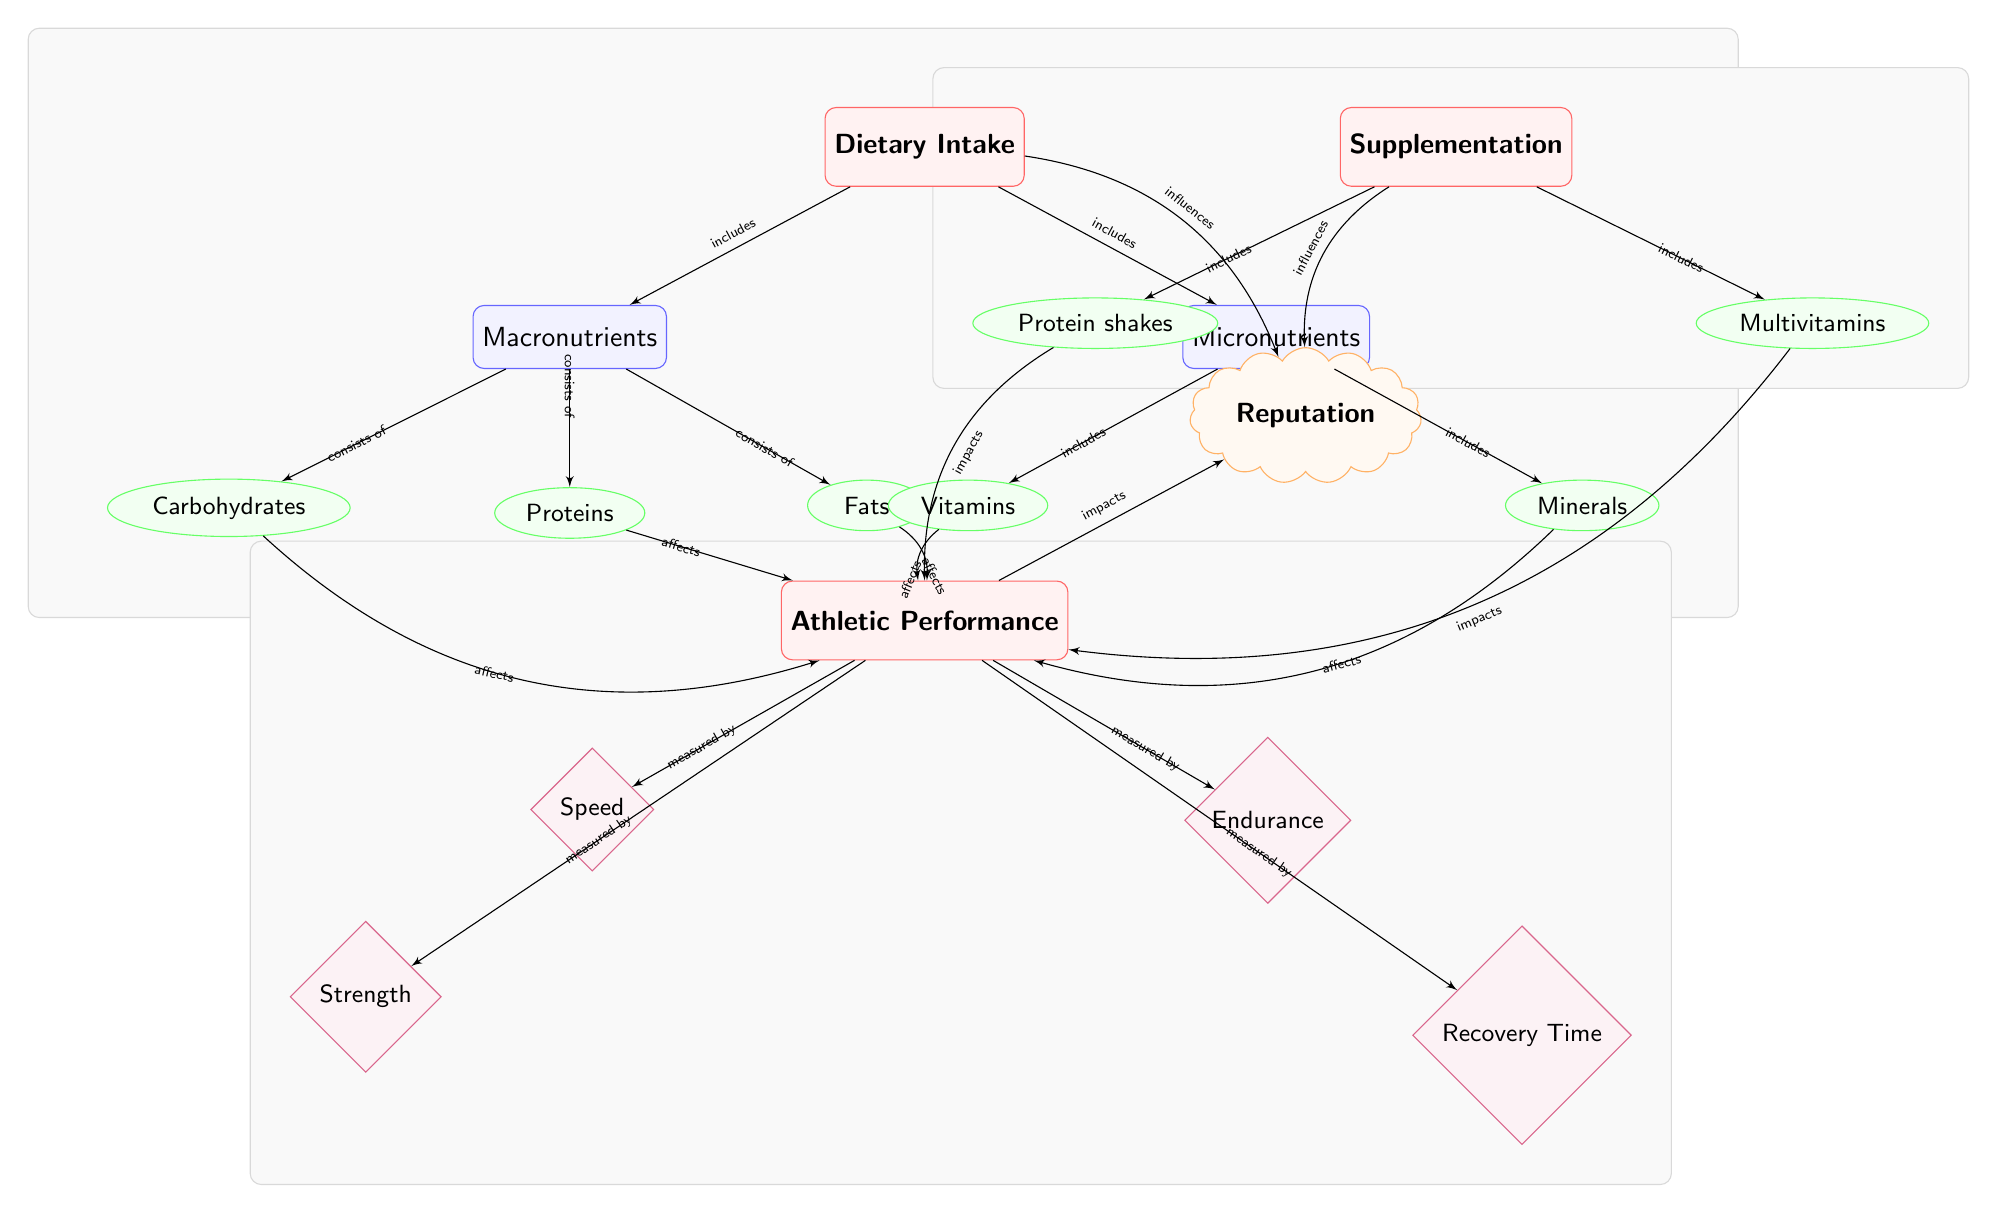What are the two main categories represented in the diagram? The diagram starts with the node labeled "Dietary Intake," which branches into "Macronutrients" and "Micronutrients." Therefore, these are the two main categories shown.
Answer: Macronutrients, Micronutrients How many subcategories fall under Macronutrients? The "Macronutrients" node has three sub-nodes connected to it: "Carbohydrates," "Proteins," and "Fats." Counting these gives a total of three subcategories.
Answer: Three Which elements under Dietary Intake impact Athletic Performance? The diagram shows arrows pointing from "Carbohydrates," "Proteins," "Fats," "Vitamins," and "Minerals" to the "Athletic Performance" node, indicating they impact it.
Answer: Carbohydrates, Proteins, Fats, Vitamins, Minerals What is the relationship between Supplementation and Athletic Performance? The arrows connecting "Protein shakes" and "Multivitamins" to "Athletic Performance" indicate that both supplementation components impact athletic performance outcomes.
Answer: Impacts Which performance metrics are measured in the diagram? The athletic performance node is connected to four metrics: "Speed," "Strength," "Endurance," and "Recovery Time," indicating these are the metrics measured.
Answer: Speed, Strength, Endurance, Recovery Time How does Dietary Intake influence an athlete's Reputation? There is a direct arrow connecting the "Dietary Intake" node to the "Reputation" node, demonstrating that overall dietary habits influence the athlete's reputation.
Answer: Influences Which category contains supplementation types? The node labeled "Supplementation" has two sub-nodes: "Protein shakes" and "Multivitamins," displaying that these are types of supplementation.
Answer: Supplementation What influences an athlete's reputation according to the diagram? The connections indicate that both "Dietary Intake" and "Supplementation" have arrows leading to "Reputation," meaning both influence an athlete's reputation.
Answer: Dietary Intake, Supplementation 